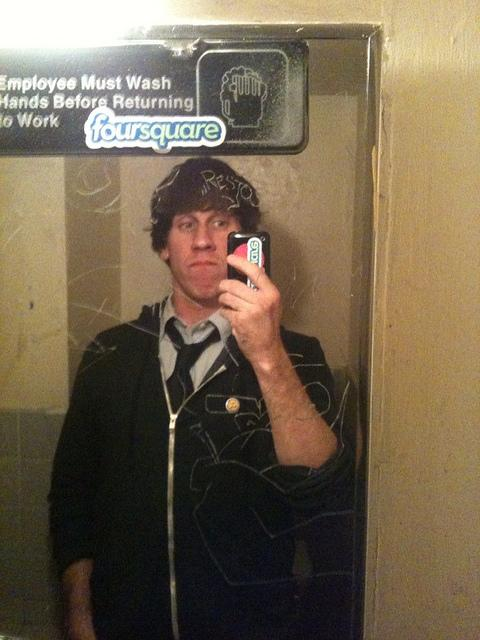Who took the photo of this man?

Choices:
A) this man
B) professional photographer
C) another woman
D) blackmailer this man 